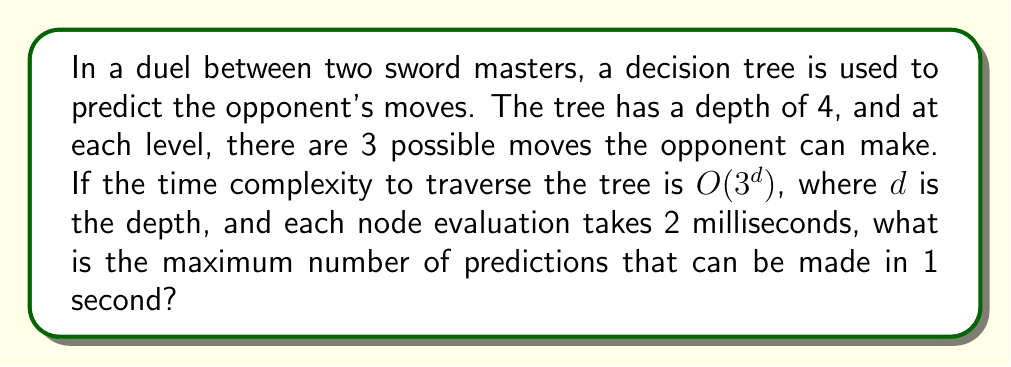Help me with this question. Let's approach this step-by-step:

1) First, we need to calculate the time it takes to traverse the entire tree:
   - The tree has a depth of 4
   - The time complexity is $O(3^d)$, where $d = 4$
   - So, the number of nodes to traverse is $3^4 = 81$

2) Each node evaluation takes 2 milliseconds:
   - Total time for one traversal = $81 \times 2 = 162$ milliseconds

3) Now, we need to determine how many of these traversals can be done in 1 second:
   - 1 second = 1000 milliseconds
   - Number of traversals = $\frac{1000}{162} \approx 6.17$

4) Since we can only make a whole number of predictions, we round down to 6.

Therefore, the maximum number of predictions that can be made in 1 second is 6.

This decision tree approach allows our sword master to quickly analyze potential moves and counter-moves, enhancing their ability to anticipate and react to the opponent's strategy in the heat of the duel.
Answer: 6 predictions 